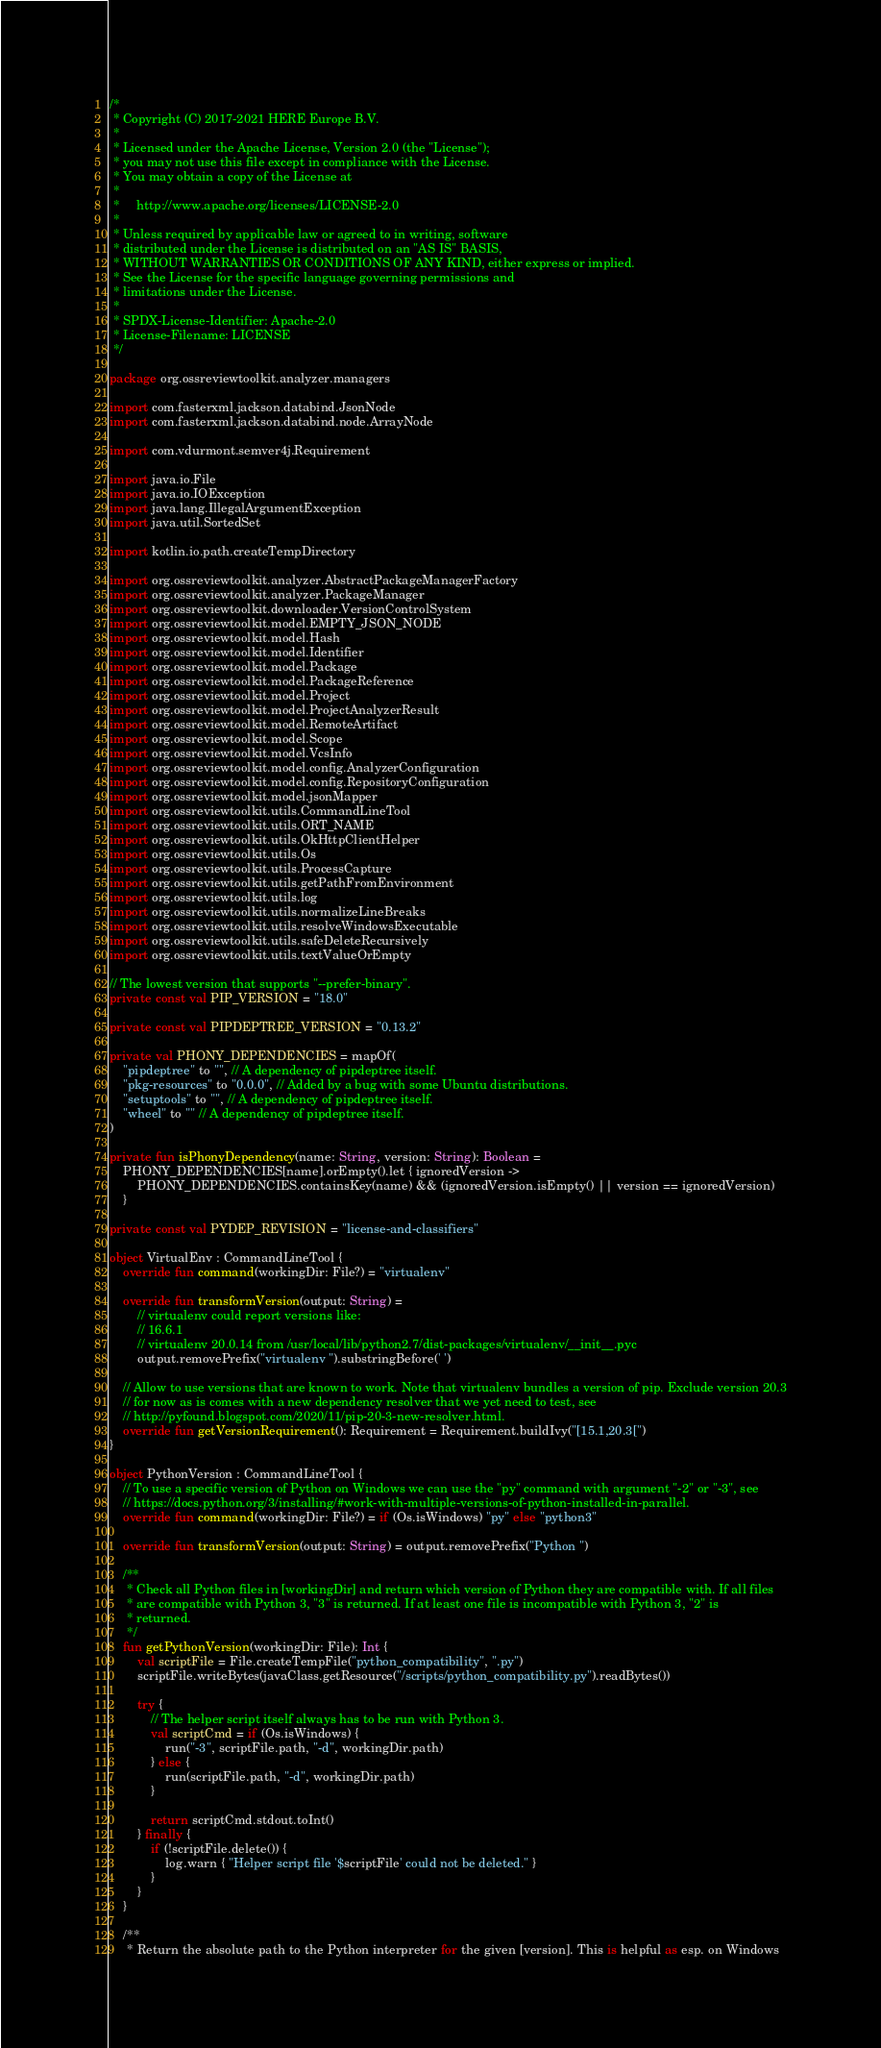<code> <loc_0><loc_0><loc_500><loc_500><_Kotlin_>/*
 * Copyright (C) 2017-2021 HERE Europe B.V.
 *
 * Licensed under the Apache License, Version 2.0 (the "License");
 * you may not use this file except in compliance with the License.
 * You may obtain a copy of the License at
 *
 *     http://www.apache.org/licenses/LICENSE-2.0
 *
 * Unless required by applicable law or agreed to in writing, software
 * distributed under the License is distributed on an "AS IS" BASIS,
 * WITHOUT WARRANTIES OR CONDITIONS OF ANY KIND, either express or implied.
 * See the License for the specific language governing permissions and
 * limitations under the License.
 *
 * SPDX-License-Identifier: Apache-2.0
 * License-Filename: LICENSE
 */

package org.ossreviewtoolkit.analyzer.managers

import com.fasterxml.jackson.databind.JsonNode
import com.fasterxml.jackson.databind.node.ArrayNode

import com.vdurmont.semver4j.Requirement

import java.io.File
import java.io.IOException
import java.lang.IllegalArgumentException
import java.util.SortedSet

import kotlin.io.path.createTempDirectory

import org.ossreviewtoolkit.analyzer.AbstractPackageManagerFactory
import org.ossreviewtoolkit.analyzer.PackageManager
import org.ossreviewtoolkit.downloader.VersionControlSystem
import org.ossreviewtoolkit.model.EMPTY_JSON_NODE
import org.ossreviewtoolkit.model.Hash
import org.ossreviewtoolkit.model.Identifier
import org.ossreviewtoolkit.model.Package
import org.ossreviewtoolkit.model.PackageReference
import org.ossreviewtoolkit.model.Project
import org.ossreviewtoolkit.model.ProjectAnalyzerResult
import org.ossreviewtoolkit.model.RemoteArtifact
import org.ossreviewtoolkit.model.Scope
import org.ossreviewtoolkit.model.VcsInfo
import org.ossreviewtoolkit.model.config.AnalyzerConfiguration
import org.ossreviewtoolkit.model.config.RepositoryConfiguration
import org.ossreviewtoolkit.model.jsonMapper
import org.ossreviewtoolkit.utils.CommandLineTool
import org.ossreviewtoolkit.utils.ORT_NAME
import org.ossreviewtoolkit.utils.OkHttpClientHelper
import org.ossreviewtoolkit.utils.Os
import org.ossreviewtoolkit.utils.ProcessCapture
import org.ossreviewtoolkit.utils.getPathFromEnvironment
import org.ossreviewtoolkit.utils.log
import org.ossreviewtoolkit.utils.normalizeLineBreaks
import org.ossreviewtoolkit.utils.resolveWindowsExecutable
import org.ossreviewtoolkit.utils.safeDeleteRecursively
import org.ossreviewtoolkit.utils.textValueOrEmpty

// The lowest version that supports "--prefer-binary".
private const val PIP_VERSION = "18.0"

private const val PIPDEPTREE_VERSION = "0.13.2"

private val PHONY_DEPENDENCIES = mapOf(
    "pipdeptree" to "", // A dependency of pipdeptree itself.
    "pkg-resources" to "0.0.0", // Added by a bug with some Ubuntu distributions.
    "setuptools" to "", // A dependency of pipdeptree itself.
    "wheel" to "" // A dependency of pipdeptree itself.
)

private fun isPhonyDependency(name: String, version: String): Boolean =
    PHONY_DEPENDENCIES[name].orEmpty().let { ignoredVersion ->
        PHONY_DEPENDENCIES.containsKey(name) && (ignoredVersion.isEmpty() || version == ignoredVersion)
    }

private const val PYDEP_REVISION = "license-and-classifiers"

object VirtualEnv : CommandLineTool {
    override fun command(workingDir: File?) = "virtualenv"

    override fun transformVersion(output: String) =
        // virtualenv could report versions like:
        // 16.6.1
        // virtualenv 20.0.14 from /usr/local/lib/python2.7/dist-packages/virtualenv/__init__.pyc
        output.removePrefix("virtualenv ").substringBefore(' ')

    // Allow to use versions that are known to work. Note that virtualenv bundles a version of pip. Exclude version 20.3
    // for now as is comes with a new dependency resolver that we yet need to test, see
    // http://pyfound.blogspot.com/2020/11/pip-20-3-new-resolver.html.
    override fun getVersionRequirement(): Requirement = Requirement.buildIvy("[15.1,20.3[")
}

object PythonVersion : CommandLineTool {
    // To use a specific version of Python on Windows we can use the "py" command with argument "-2" or "-3", see
    // https://docs.python.org/3/installing/#work-with-multiple-versions-of-python-installed-in-parallel.
    override fun command(workingDir: File?) = if (Os.isWindows) "py" else "python3"

    override fun transformVersion(output: String) = output.removePrefix("Python ")

    /**
     * Check all Python files in [workingDir] and return which version of Python they are compatible with. If all files
     * are compatible with Python 3, "3" is returned. If at least one file is incompatible with Python 3, "2" is
     * returned.
     */
    fun getPythonVersion(workingDir: File): Int {
        val scriptFile = File.createTempFile("python_compatibility", ".py")
        scriptFile.writeBytes(javaClass.getResource("/scripts/python_compatibility.py").readBytes())

        try {
            // The helper script itself always has to be run with Python 3.
            val scriptCmd = if (Os.isWindows) {
                run("-3", scriptFile.path, "-d", workingDir.path)
            } else {
                run(scriptFile.path, "-d", workingDir.path)
            }

            return scriptCmd.stdout.toInt()
        } finally {
            if (!scriptFile.delete()) {
                log.warn { "Helper script file '$scriptFile' could not be deleted." }
            }
        }
    }

    /**
     * Return the absolute path to the Python interpreter for the given [version]. This is helpful as esp. on Windows</code> 